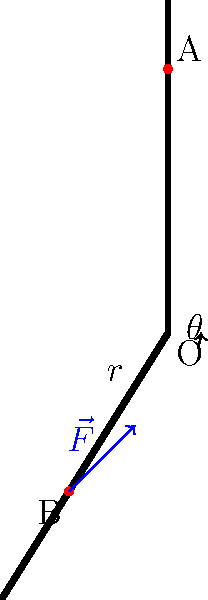In the human arm model shown, a muscle exerts a force $\vec{F}$ of magnitude 100 N at point B. The moment arm $r$ is 40 cm, and the angle $\theta$ between the force vector and the moment arm is 30°. Calculate the magnitude of the torque produced about point O. To solve this problem, we'll use the formula for torque:

$$\tau = r F \sin(\theta)$$

Where:
- $\tau$ is the torque
- $r$ is the moment arm
- $F$ is the magnitude of the force
- $\theta$ is the angle between the force vector and the moment arm

Given:
- $F = 100$ N
- $r = 40$ cm = 0.4 m
- $\theta = 30°$

Step 1: Convert the angle to radians (optional, as most calculators can work with degrees)
$$30° \times \frac{\pi}{180°} = 0.5236 \text{ radians}$$

Step 2: Substitute the values into the torque equation
$$\tau = 0.4 \text{ m} \times 100 \text{ N} \times \sin(30°)$$

Step 3: Calculate the sine of 30°
$$\sin(30°) = 0.5$$

Step 4: Perform the final calculation
$$\tau = 0.4 \text{ m} \times 100 \text{ N} \times 0.5 = 20 \text{ N·m}$$

Therefore, the magnitude of the torque produced about point O is 20 N·m.
Answer: 20 N·m 